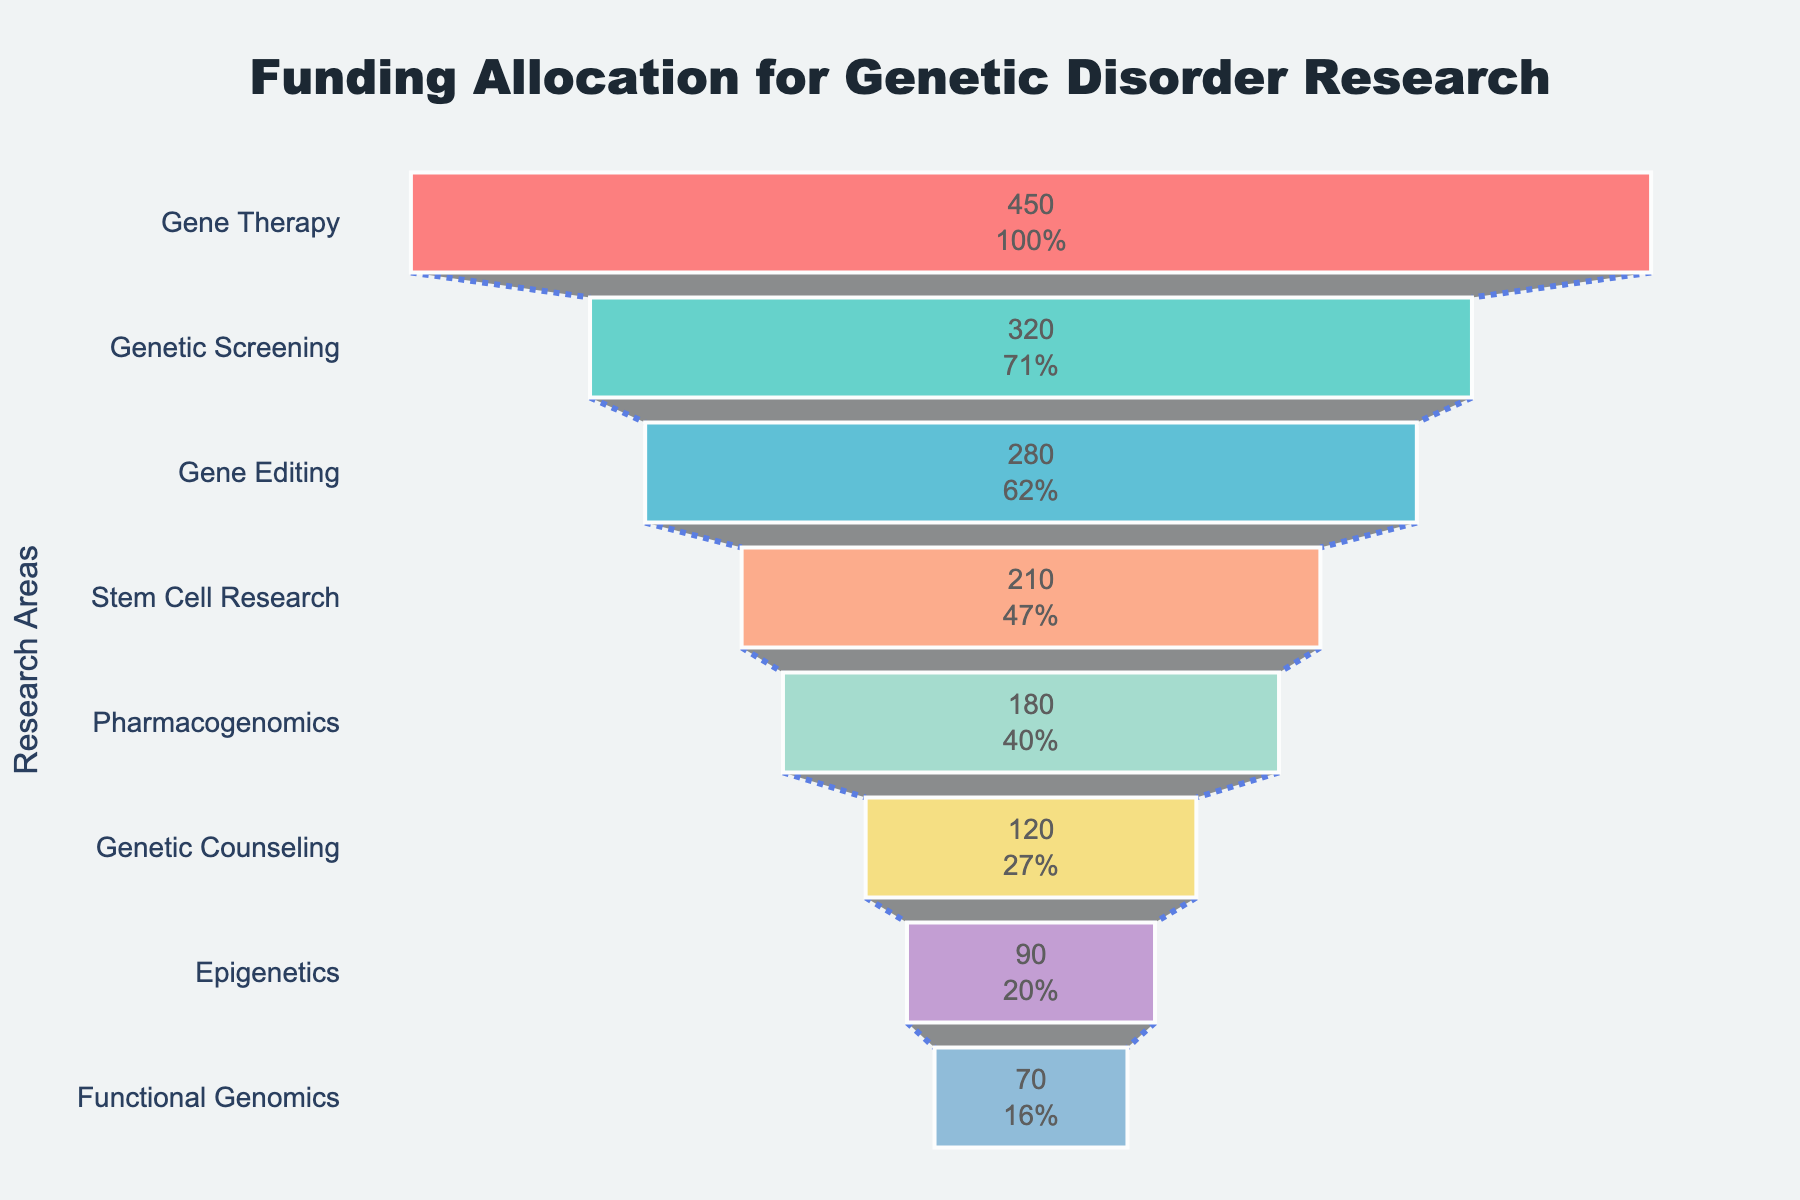What's the largest funded research area? The figure shows funding amounts for various genetic disorder research areas. The largest bar, "Gene Therapy," represents the highest funding allocation.
Answer: Gene Therapy Which research areas received more funding than Stem Cell Research? To answer this, compare the funding amounts of all research areas with Stem Cell Research. Gene Therapy, Genetic Screening, and Gene Editing have higher funding amounts.
Answer: Gene Therapy, Genetic Screening, Gene Editing What is the total amount of funding for all research areas? Sum the funding amounts for all research areas: 450 + 320 + 280 + 210 + 180 + 120 + 90 + 70.
Answer: 1720 Million USD How much more funding does Gene Therapy receive compared to Genetic Counseling? Subtract the funding of Genetic Counseling from Gene Therapy: 450 - 120.
Answer: 330 Million USD Which research area has the least amount of funding? The figure shows that the smallest bar, "Functional Genomics," has the least funding.
Answer: Functional Genomics What is the average funding amount for all the research areas? Calculate the average by summing the total funding (1720) and dividing by the number of research areas (8). 1720 / 8 = 215.
Answer: 215 Million USD How does the funding for Genetic Screening compare to Gene Editing? The figure shows that Genetic Screening receives 320 million USD, while Gene Editing receives 280 million USD. Thus, Genetic Screening receives more funding.
Answer: Genetic Screening receives more What percentage of the total funding is allocated to Pharmacogenomics? First, calculate the total funding (1720), then find the percentage: (180 / 1720) * 100.
Answer: 10.47% What are the combined funding amounts for the three least funded areas? Add the funding amounts for Genetic Counseling, Epigenetics, and Functional Genomics: 120 + 90 + 70.
Answer: 280 Million USD What is the difference in funding between the highest and lowest funded research areas? Subtract the funding of Functional Genomics (70) from Gene Therapy (450): 450 - 70.
Answer: 380 Million USD 